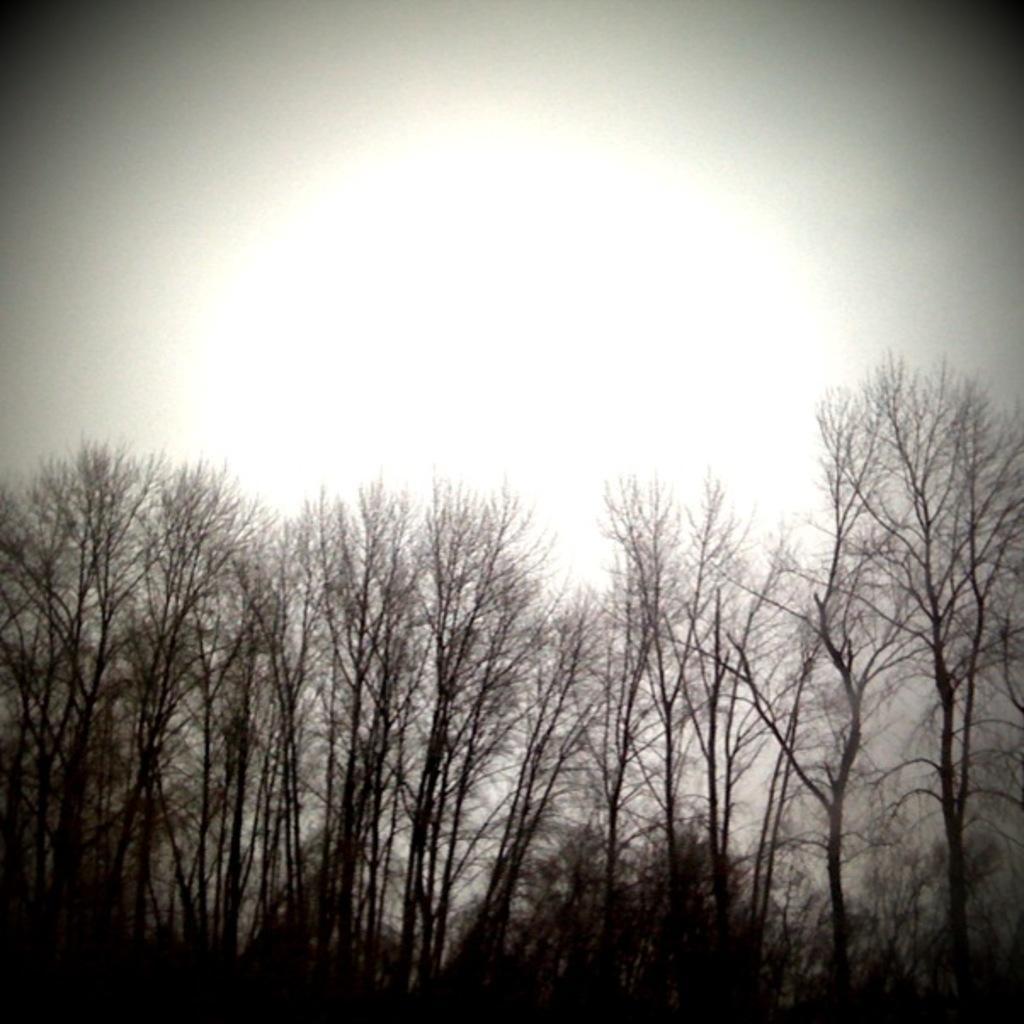Please provide a concise description of this image. In this picture we can see trees. In the background of the image we can see the sky. 